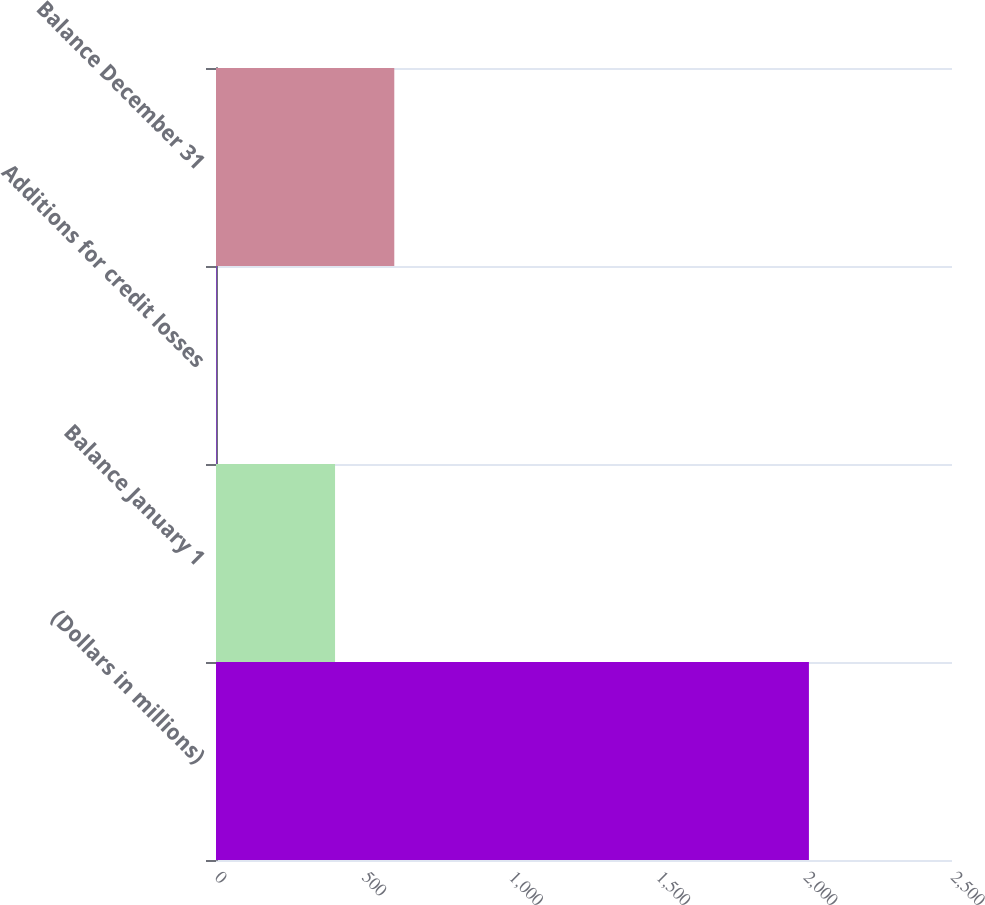Convert chart. <chart><loc_0><loc_0><loc_500><loc_500><bar_chart><fcel>(Dollars in millions)<fcel>Balance January 1<fcel>Additions for credit losses<fcel>Balance December 31<nl><fcel>2014<fcel>404.4<fcel>2<fcel>605.6<nl></chart> 